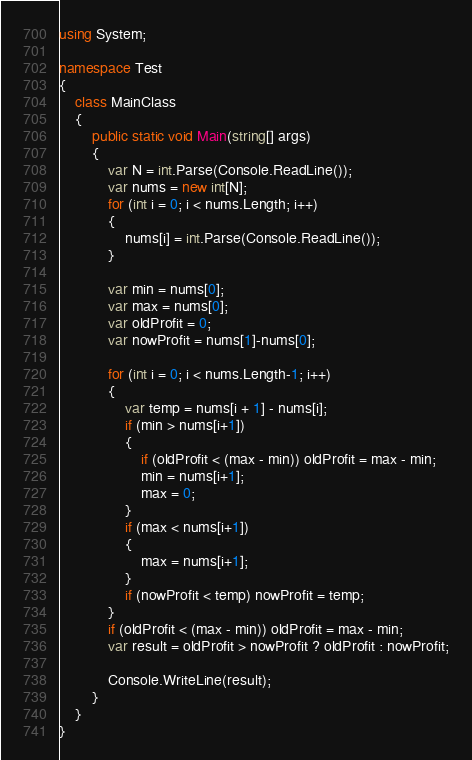Convert code to text. <code><loc_0><loc_0><loc_500><loc_500><_C#_>using System;

namespace Test
{
    class MainClass
    {
        public static void Main(string[] args)
        {
            var N = int.Parse(Console.ReadLine());
            var nums = new int[N];
            for (int i = 0; i < nums.Length; i++)
            {
                nums[i] = int.Parse(Console.ReadLine());
            }

            var min = nums[0];
            var max = nums[0];
            var oldProfit = 0;
            var nowProfit = nums[1]-nums[0];

            for (int i = 0; i < nums.Length-1; i++)
            {
                var temp = nums[i + 1] - nums[i];
                if (min > nums[i+1])
                {
                    if (oldProfit < (max - min)) oldProfit = max - min;
                    min = nums[i+1];
                    max = 0;
                }
                if (max < nums[i+1])
                {
                    max = nums[i+1];
                }
                if (nowProfit < temp) nowProfit = temp;
            }
            if (oldProfit < (max - min)) oldProfit = max - min;
            var result = oldProfit > nowProfit ? oldProfit : nowProfit;

            Console.WriteLine(result);
        }
    }
}</code> 